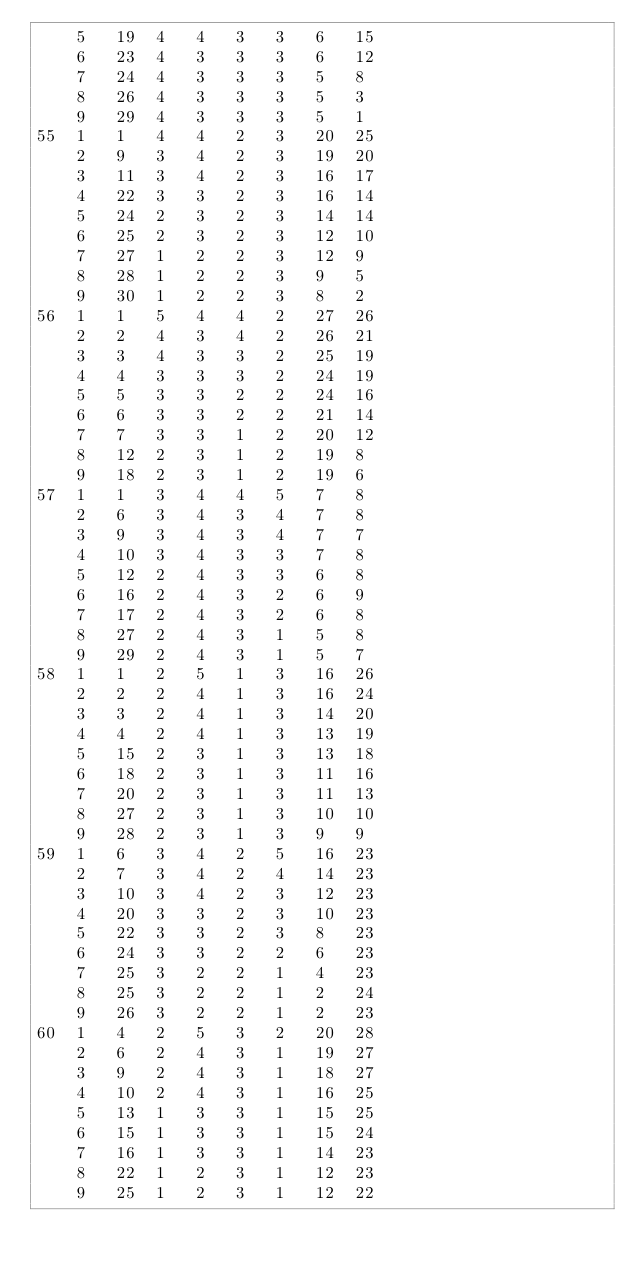Convert code to text. <code><loc_0><loc_0><loc_500><loc_500><_ObjectiveC_>	5	19	4	4	3	3	6	15	
	6	23	4	3	3	3	6	12	
	7	24	4	3	3	3	5	8	
	8	26	4	3	3	3	5	3	
	9	29	4	3	3	3	5	1	
55	1	1	4	4	2	3	20	25	
	2	9	3	4	2	3	19	20	
	3	11	3	4	2	3	16	17	
	4	22	3	3	2	3	16	14	
	5	24	2	3	2	3	14	14	
	6	25	2	3	2	3	12	10	
	7	27	1	2	2	3	12	9	
	8	28	1	2	2	3	9	5	
	9	30	1	2	2	3	8	2	
56	1	1	5	4	4	2	27	26	
	2	2	4	3	4	2	26	21	
	3	3	4	3	3	2	25	19	
	4	4	3	3	3	2	24	19	
	5	5	3	3	2	2	24	16	
	6	6	3	3	2	2	21	14	
	7	7	3	3	1	2	20	12	
	8	12	2	3	1	2	19	8	
	9	18	2	3	1	2	19	6	
57	1	1	3	4	4	5	7	8	
	2	6	3	4	3	4	7	8	
	3	9	3	4	3	4	7	7	
	4	10	3	4	3	3	7	8	
	5	12	2	4	3	3	6	8	
	6	16	2	4	3	2	6	9	
	7	17	2	4	3	2	6	8	
	8	27	2	4	3	1	5	8	
	9	29	2	4	3	1	5	7	
58	1	1	2	5	1	3	16	26	
	2	2	2	4	1	3	16	24	
	3	3	2	4	1	3	14	20	
	4	4	2	4	1	3	13	19	
	5	15	2	3	1	3	13	18	
	6	18	2	3	1	3	11	16	
	7	20	2	3	1	3	11	13	
	8	27	2	3	1	3	10	10	
	9	28	2	3	1	3	9	9	
59	1	6	3	4	2	5	16	23	
	2	7	3	4	2	4	14	23	
	3	10	3	4	2	3	12	23	
	4	20	3	3	2	3	10	23	
	5	22	3	3	2	3	8	23	
	6	24	3	3	2	2	6	23	
	7	25	3	2	2	1	4	23	
	8	25	3	2	2	1	2	24	
	9	26	3	2	2	1	2	23	
60	1	4	2	5	3	2	20	28	
	2	6	2	4	3	1	19	27	
	3	9	2	4	3	1	18	27	
	4	10	2	4	3	1	16	25	
	5	13	1	3	3	1	15	25	
	6	15	1	3	3	1	15	24	
	7	16	1	3	3	1	14	23	
	8	22	1	2	3	1	12	23	
	9	25	1	2	3	1	12	22	</code> 